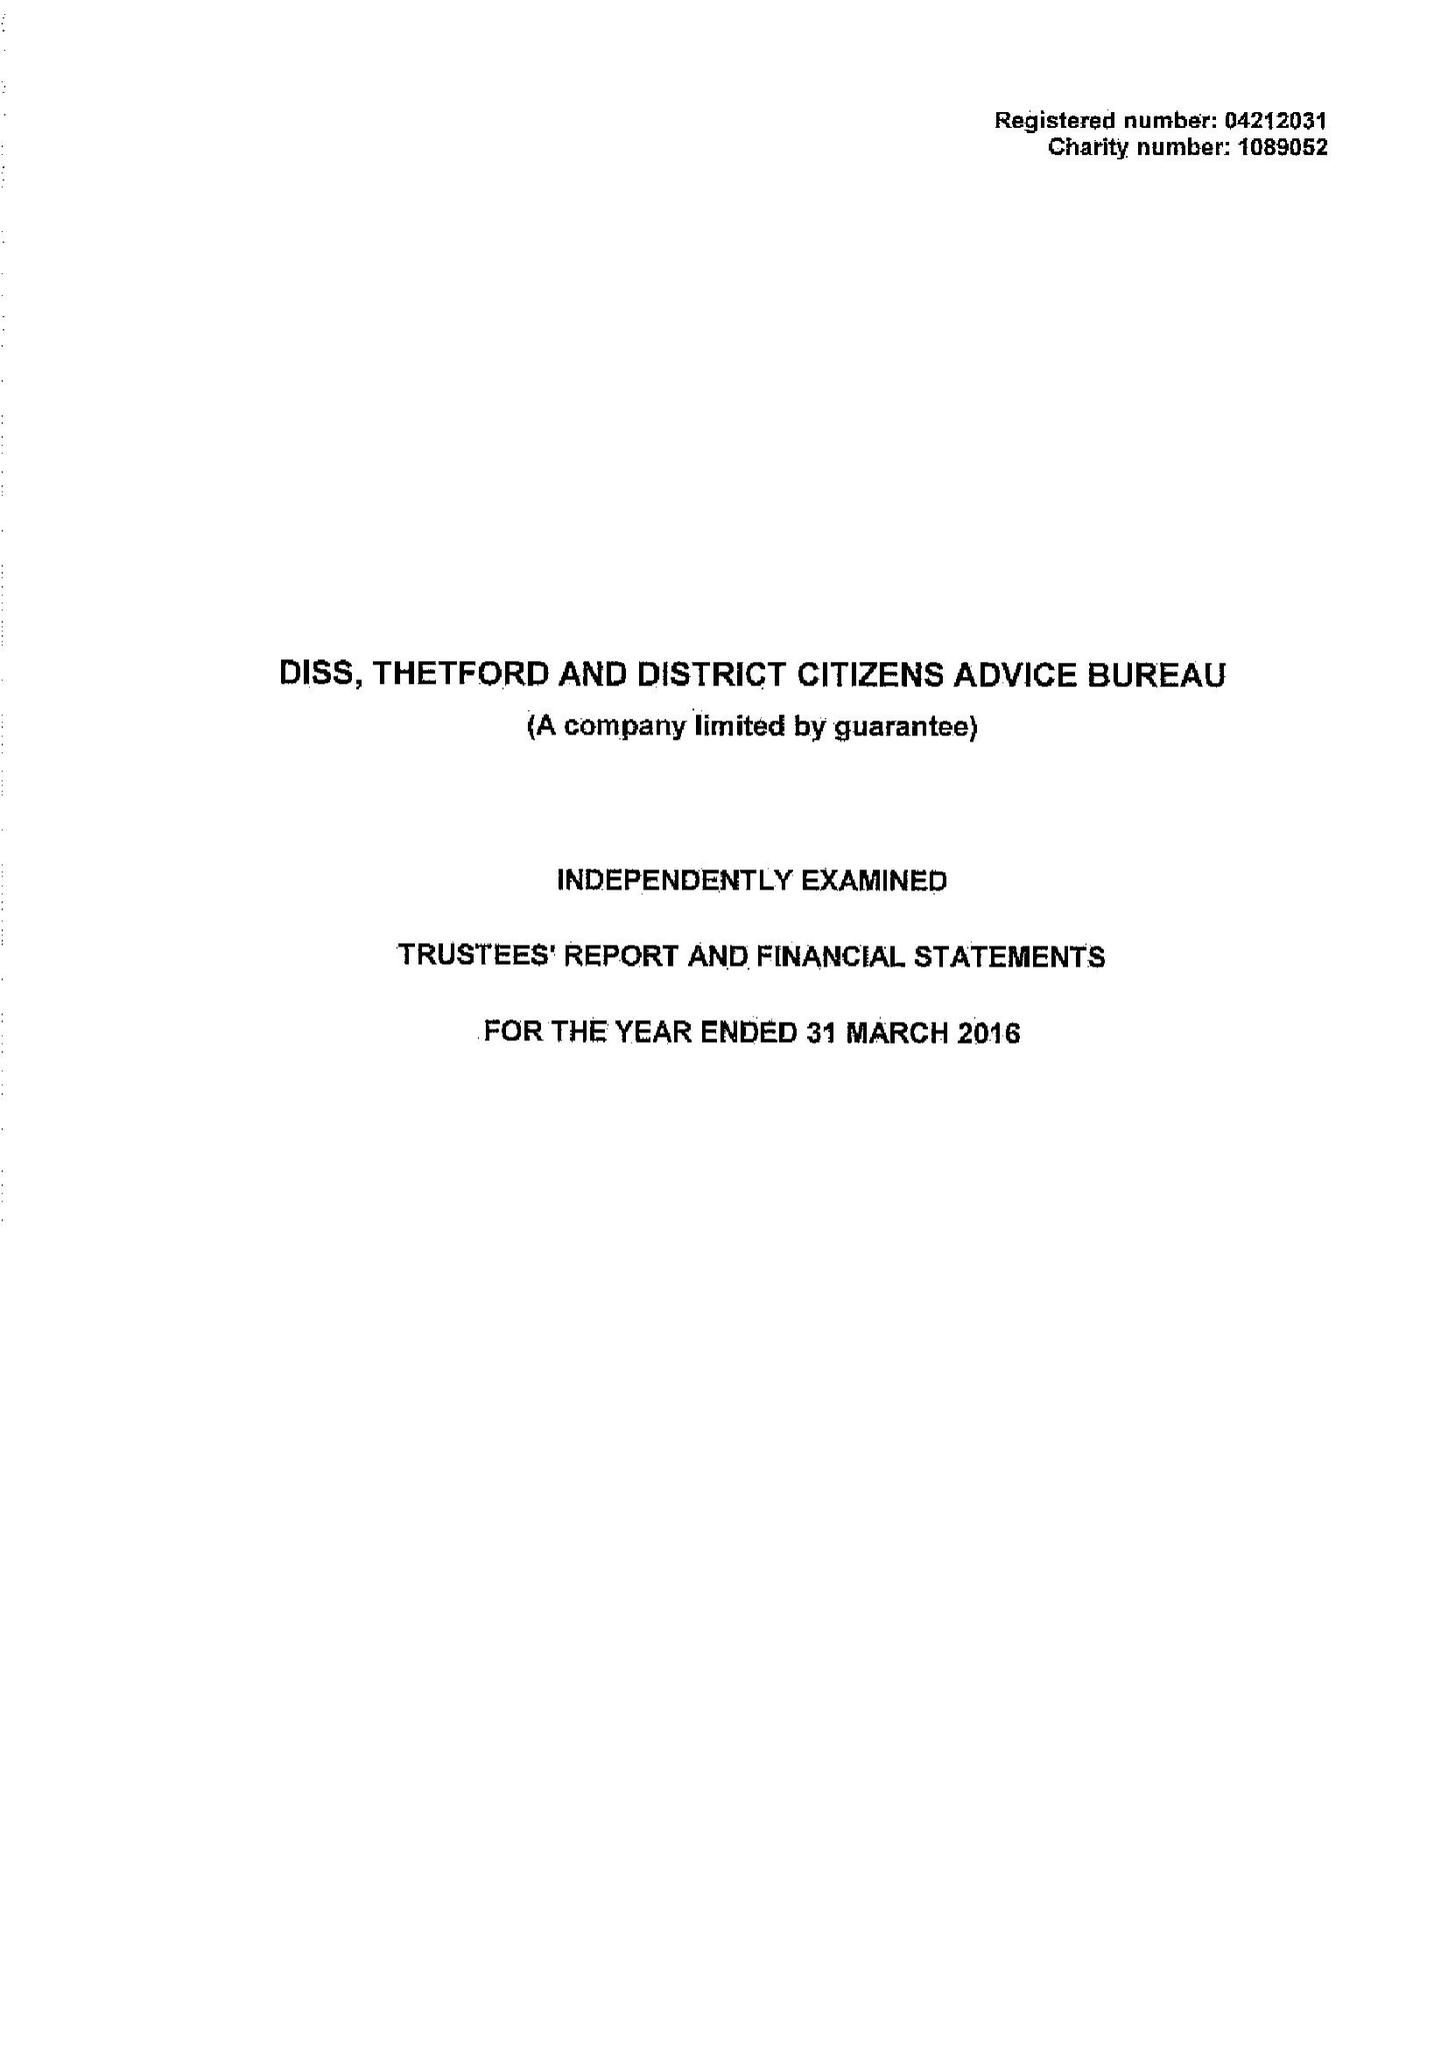What is the value for the charity_name?
Answer the question using a single word or phrase. Diss, Thetford and District Citizens Advice Bureau 